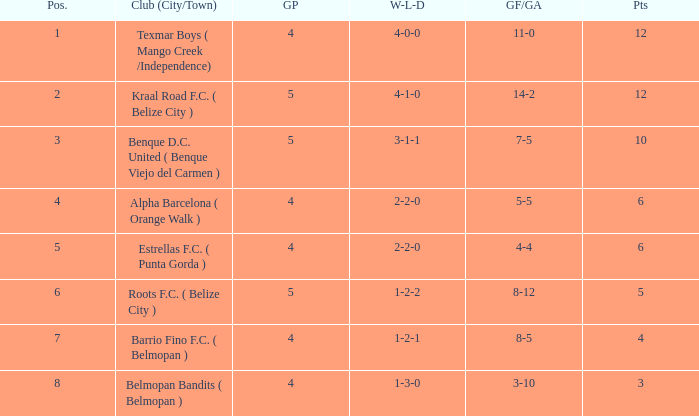What's the goals for/against with w-l-d being 3-1-1 7-5. 